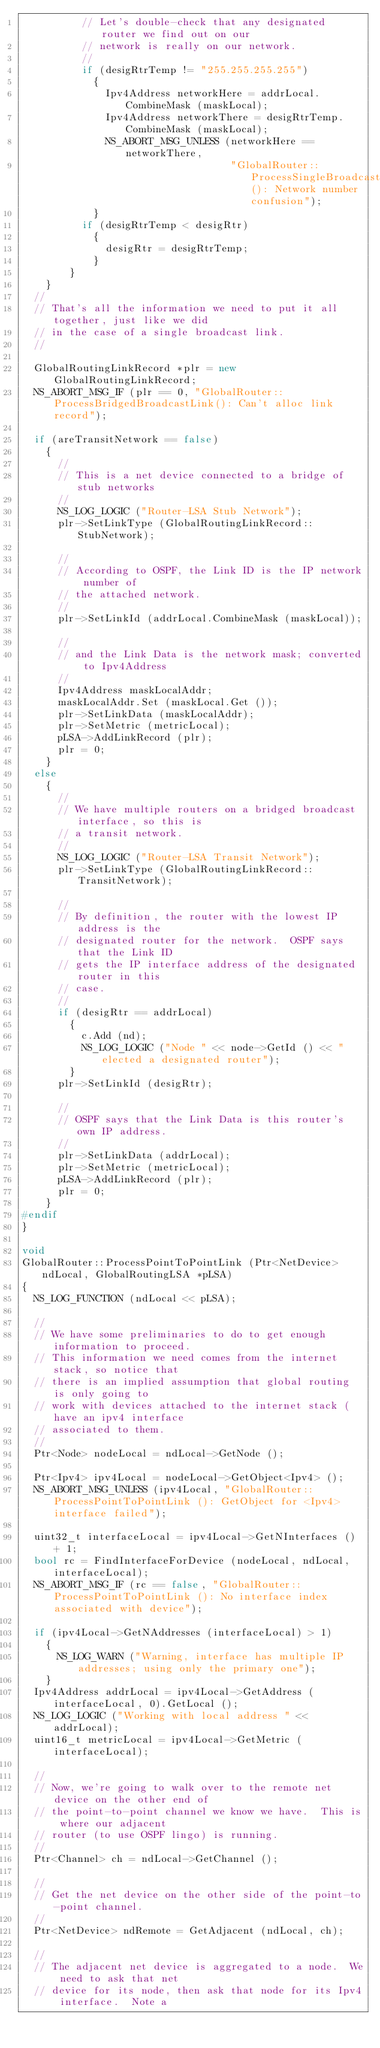Convert code to text. <code><loc_0><loc_0><loc_500><loc_500><_C++_>          // Let's double-check that any designated router we find out on our
          // network is really on our network.
          //
          if (desigRtrTemp != "255.255.255.255")
            {
              Ipv4Address networkHere = addrLocal.CombineMask (maskLocal);
              Ipv4Address networkThere = desigRtrTemp.CombineMask (maskLocal);
              NS_ABORT_MSG_UNLESS (networkHere == networkThere, 
                                   "GlobalRouter::ProcessSingleBroadcastLink(): Network number confusion");
            }
          if (desigRtrTemp < desigRtr)
            {
              desigRtr = desigRtrTemp;
            }
        }
    }
  //
  // That's all the information we need to put it all together, just like we did
  // in the case of a single broadcast link.
  //

  GlobalRoutingLinkRecord *plr = new GlobalRoutingLinkRecord;
  NS_ABORT_MSG_IF (plr == 0, "GlobalRouter::ProcessBridgedBroadcastLink(): Can't alloc link record");

  if (areTransitNetwork == false)
    {
      //
      // This is a net device connected to a bridge of stub networks
      //
      NS_LOG_LOGIC ("Router-LSA Stub Network");
      plr->SetLinkType (GlobalRoutingLinkRecord::StubNetwork);

      // 
      // According to OSPF, the Link ID is the IP network number of 
      // the attached network.
      //
      plr->SetLinkId (addrLocal.CombineMask (maskLocal));

      //
      // and the Link Data is the network mask; converted to Ipv4Address
      //
      Ipv4Address maskLocalAddr;
      maskLocalAddr.Set (maskLocal.Get ());
      plr->SetLinkData (maskLocalAddr);
      plr->SetMetric (metricLocal);
      pLSA->AddLinkRecord (plr);
      plr = 0;
    }
  else
    {
      //
      // We have multiple routers on a bridged broadcast interface, so this is
      // a transit network.
      //
      NS_LOG_LOGIC ("Router-LSA Transit Network");
      plr->SetLinkType (GlobalRoutingLinkRecord::TransitNetwork);

      // 
      // By definition, the router with the lowest IP address is the
      // designated router for the network.  OSPF says that the Link ID
      // gets the IP interface address of the designated router in this 
      // case.
      //
      if (desigRtr == addrLocal) 
        {
          c.Add (nd);
          NS_LOG_LOGIC ("Node " << node->GetId () << " elected a designated router");
        }
      plr->SetLinkId (desigRtr);

      //
      // OSPF says that the Link Data is this router's own IP address.
      //
      plr->SetLinkData (addrLocal);
      plr->SetMetric (metricLocal);
      pLSA->AddLinkRecord (plr);
      plr = 0;
    }
#endif
}

void
GlobalRouter::ProcessPointToPointLink (Ptr<NetDevice> ndLocal, GlobalRoutingLSA *pLSA)
{
  NS_LOG_FUNCTION (ndLocal << pLSA);

  //
  // We have some preliminaries to do to get enough information to proceed.
  // This information we need comes from the internet stack, so notice that
  // there is an implied assumption that global routing is only going to 
  // work with devices attached to the internet stack (have an ipv4 interface
  // associated to them.
  //
  Ptr<Node> nodeLocal = ndLocal->GetNode ();

  Ptr<Ipv4> ipv4Local = nodeLocal->GetObject<Ipv4> ();
  NS_ABORT_MSG_UNLESS (ipv4Local, "GlobalRouter::ProcessPointToPointLink (): GetObject for <Ipv4> interface failed");

  uint32_t interfaceLocal = ipv4Local->GetNInterfaces () + 1;
  bool rc = FindInterfaceForDevice (nodeLocal, ndLocal, interfaceLocal);
  NS_ABORT_MSG_IF (rc == false, "GlobalRouter::ProcessPointToPointLink (): No interface index associated with device");

  if (ipv4Local->GetNAddresses (interfaceLocal) > 1)
    {
      NS_LOG_WARN ("Warning, interface has multiple IP addresses; using only the primary one");
    }
  Ipv4Address addrLocal = ipv4Local->GetAddress (interfaceLocal, 0).GetLocal ();
  NS_LOG_LOGIC ("Working with local address " << addrLocal);
  uint16_t metricLocal = ipv4Local->GetMetric (interfaceLocal);

  //
  // Now, we're going to walk over to the remote net device on the other end of 
  // the point-to-point channel we know we have.  This is where our adjacent 
  // router (to use OSPF lingo) is running.
  //
  Ptr<Channel> ch = ndLocal->GetChannel ();

  //
  // Get the net device on the other side of the point-to-point channel.
  //
  Ptr<NetDevice> ndRemote = GetAdjacent (ndLocal, ch);

  //
  // The adjacent net device is aggregated to a node.  We need to ask that net 
  // device for its node, then ask that node for its Ipv4 interface.  Note a</code> 